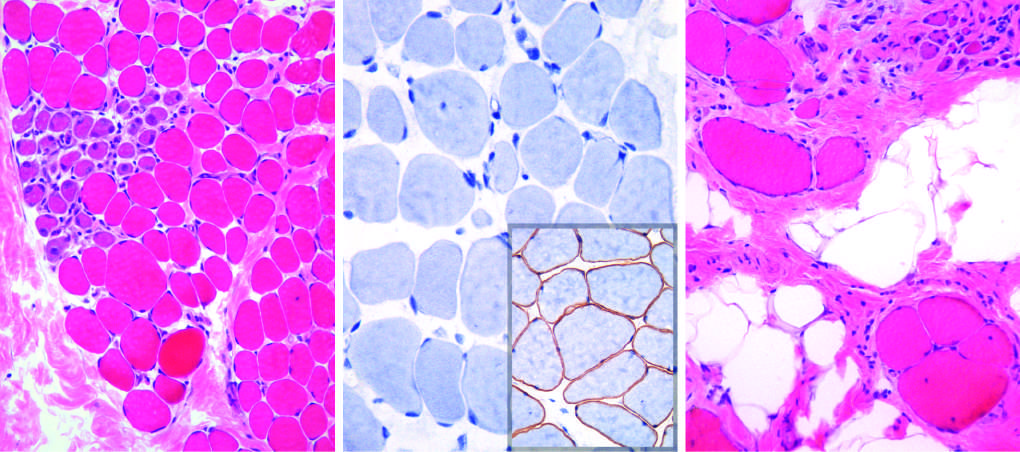does immunohistochemical staining show a complete absence of membrane-associated dystrophin, seen as a brown stain in normal muscle inset in (b)?
Answer the question using a single word or phrase. Yes 